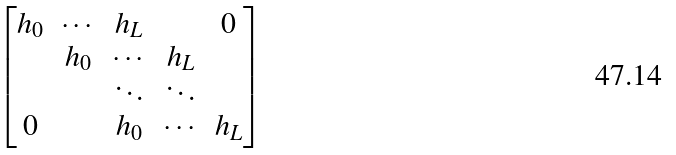<formula> <loc_0><loc_0><loc_500><loc_500>\begin{bmatrix} { h } _ { 0 } & \cdots & { h } _ { L } & & { 0 } \\ & { h } _ { 0 } & \cdots & { h } _ { L } & \\ & & \ddots & \ddots & \\ { 0 } & & { h } _ { 0 } & \cdots & { h } _ { L } \end{bmatrix}</formula> 